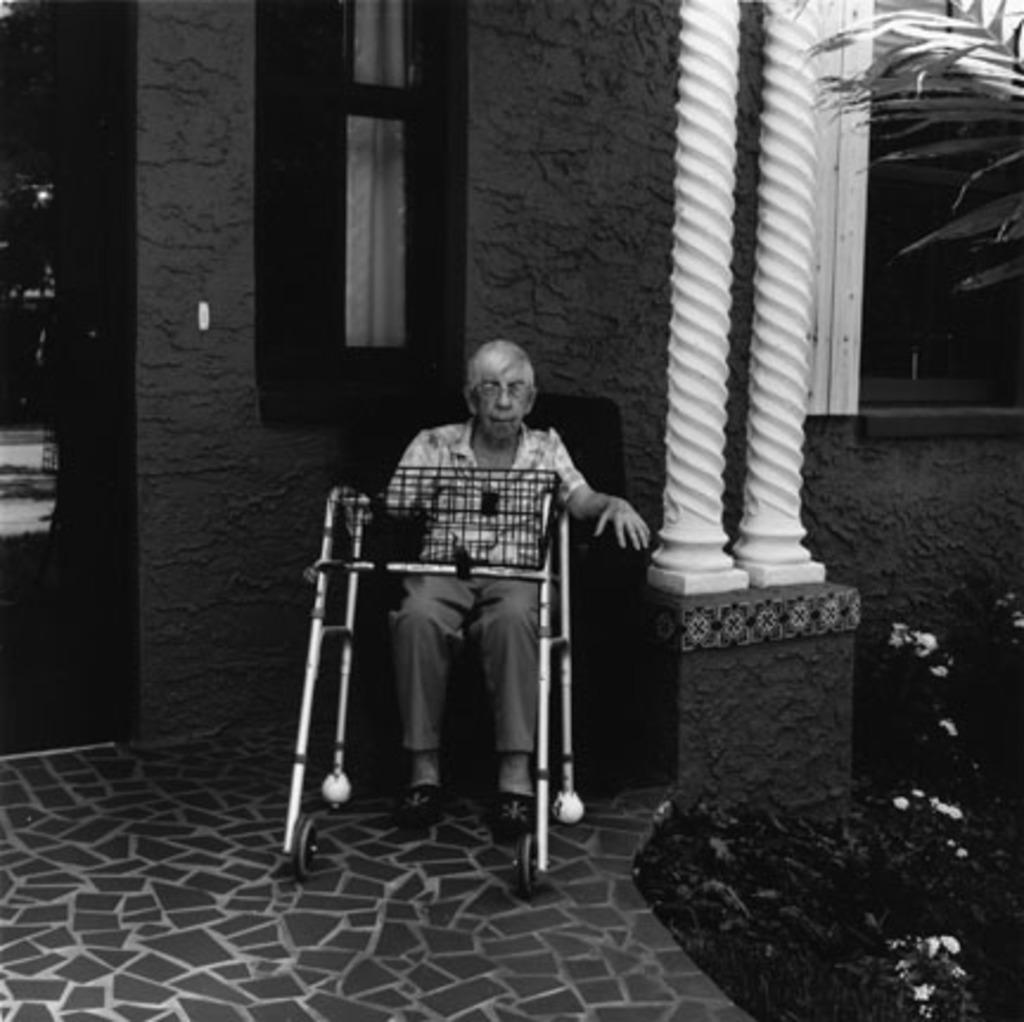What is the color scheme of the image? The image is black and white. Who is the main subject in the image? There is an old man in the image. What is the old man's position in the image? The old man is sitting on a wheelchair. What architectural features are present in front of the house? There are two white pillars in front of the house. Where is the old man located in relation to the white pillars? The man is beside the white pillars. What type of tramp can be seen performing tricks near the old man in the image? There is no tramp performing tricks in the image; it only features an old man sitting on a wheelchair beside two white pillars. What emotion does the old man express when he sees the disgusting duck in the image? There is no duck, disgusting or otherwise, present in the image. 